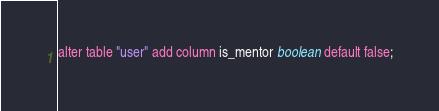<code> <loc_0><loc_0><loc_500><loc_500><_SQL_>alter table "user" add column is_mentor boolean default false;
</code> 